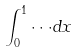Convert formula to latex. <formula><loc_0><loc_0><loc_500><loc_500>\int _ { 0 } ^ { 1 } \cdot \cdot \cdot d x</formula> 